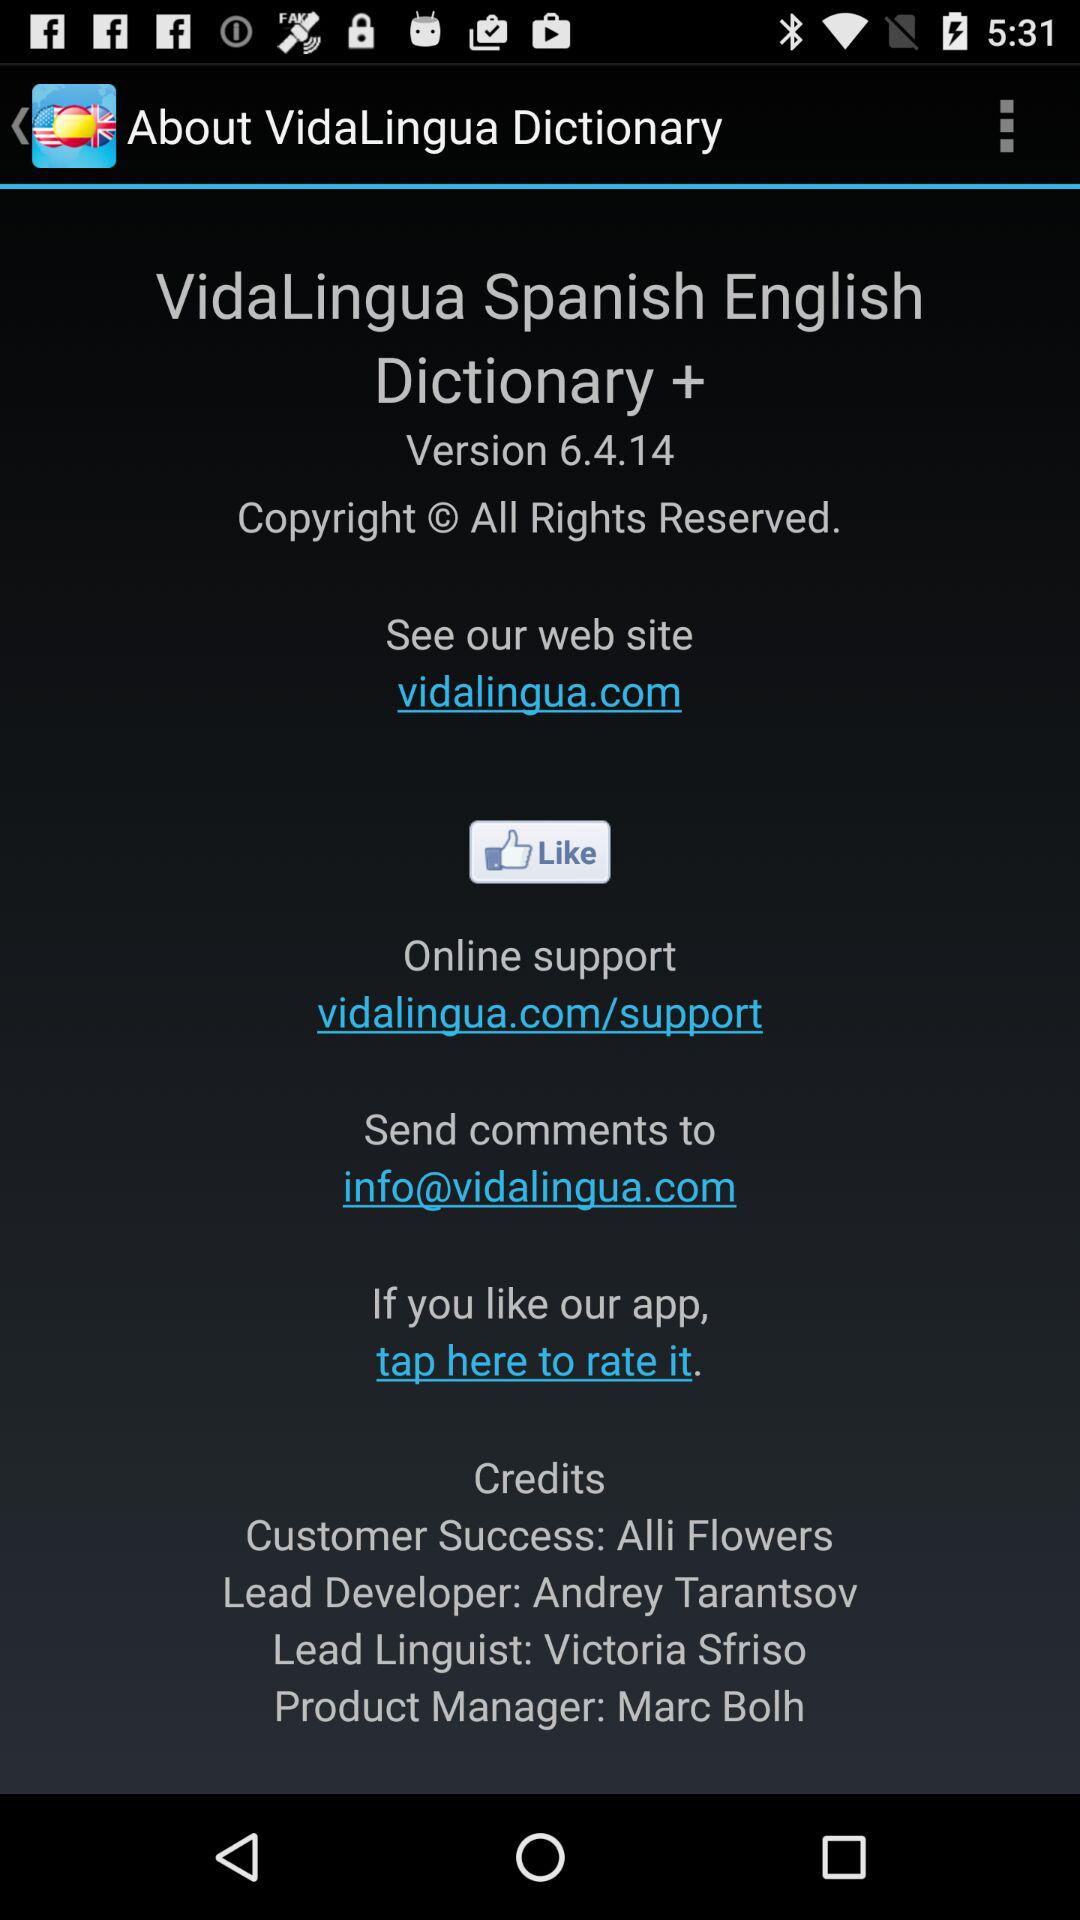Who is the product manager? The product manager is Marc Bolh. 